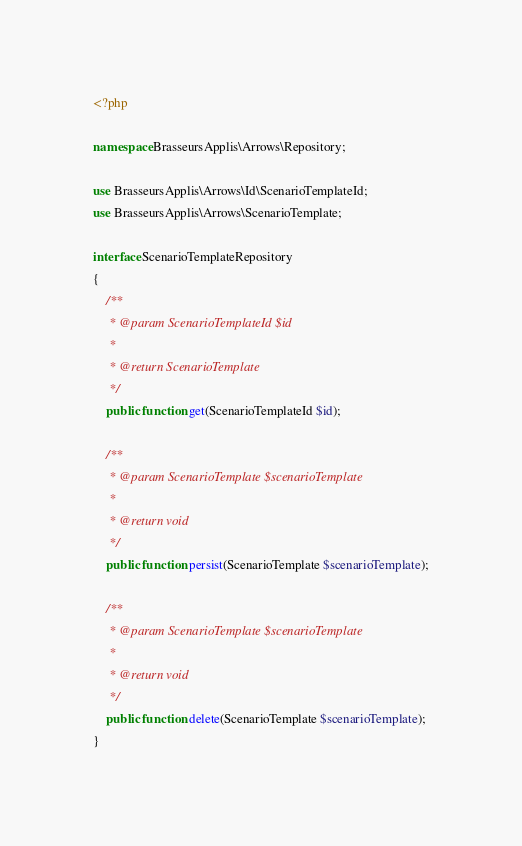Convert code to text. <code><loc_0><loc_0><loc_500><loc_500><_PHP_><?php

namespace BrasseursApplis\Arrows\Repository;

use BrasseursApplis\Arrows\Id\ScenarioTemplateId;
use BrasseursApplis\Arrows\ScenarioTemplate;

interface ScenarioTemplateRepository
{
    /**
     * @param ScenarioTemplateId $id
     *
     * @return ScenarioTemplate
     */
    public function get(ScenarioTemplateId $id);

    /**
     * @param ScenarioTemplate $scenarioTemplate
     *
     * @return void
     */
    public function persist(ScenarioTemplate $scenarioTemplate);

    /**
     * @param ScenarioTemplate $scenarioTemplate
     *
     * @return void
     */
    public function delete(ScenarioTemplate $scenarioTemplate);
}
</code> 